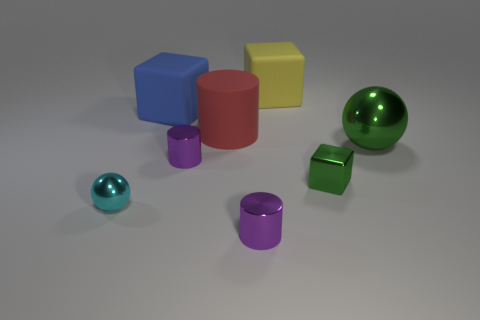Is there another cylinder of the same size as the red matte cylinder?
Offer a terse response. No. There is a block that is to the left of the tiny purple cylinder that is behind the small metal sphere; what is its size?
Your answer should be very brief. Large. What number of small shiny things have the same color as the big rubber cylinder?
Your answer should be compact. 0. What shape is the purple metallic object behind the ball left of the large yellow object?
Give a very brief answer. Cylinder. What number of other small cyan things have the same material as the tiny cyan object?
Your answer should be compact. 0. There is a cube left of the large yellow rubber block; what is it made of?
Ensure brevity in your answer.  Rubber. The tiny shiny object that is on the right side of the small cylinder that is in front of the small purple shiny object that is behind the cyan shiny ball is what shape?
Provide a short and direct response. Cube. Does the metallic object to the right of the green cube have the same color as the cube in front of the big red matte cylinder?
Offer a very short reply. Yes. Are there fewer tiny cyan balls that are on the left side of the tiny cyan metal ball than small purple shiny cylinders that are right of the big yellow object?
Ensure brevity in your answer.  No. The other metallic object that is the same shape as the cyan thing is what color?
Provide a short and direct response. Green. 